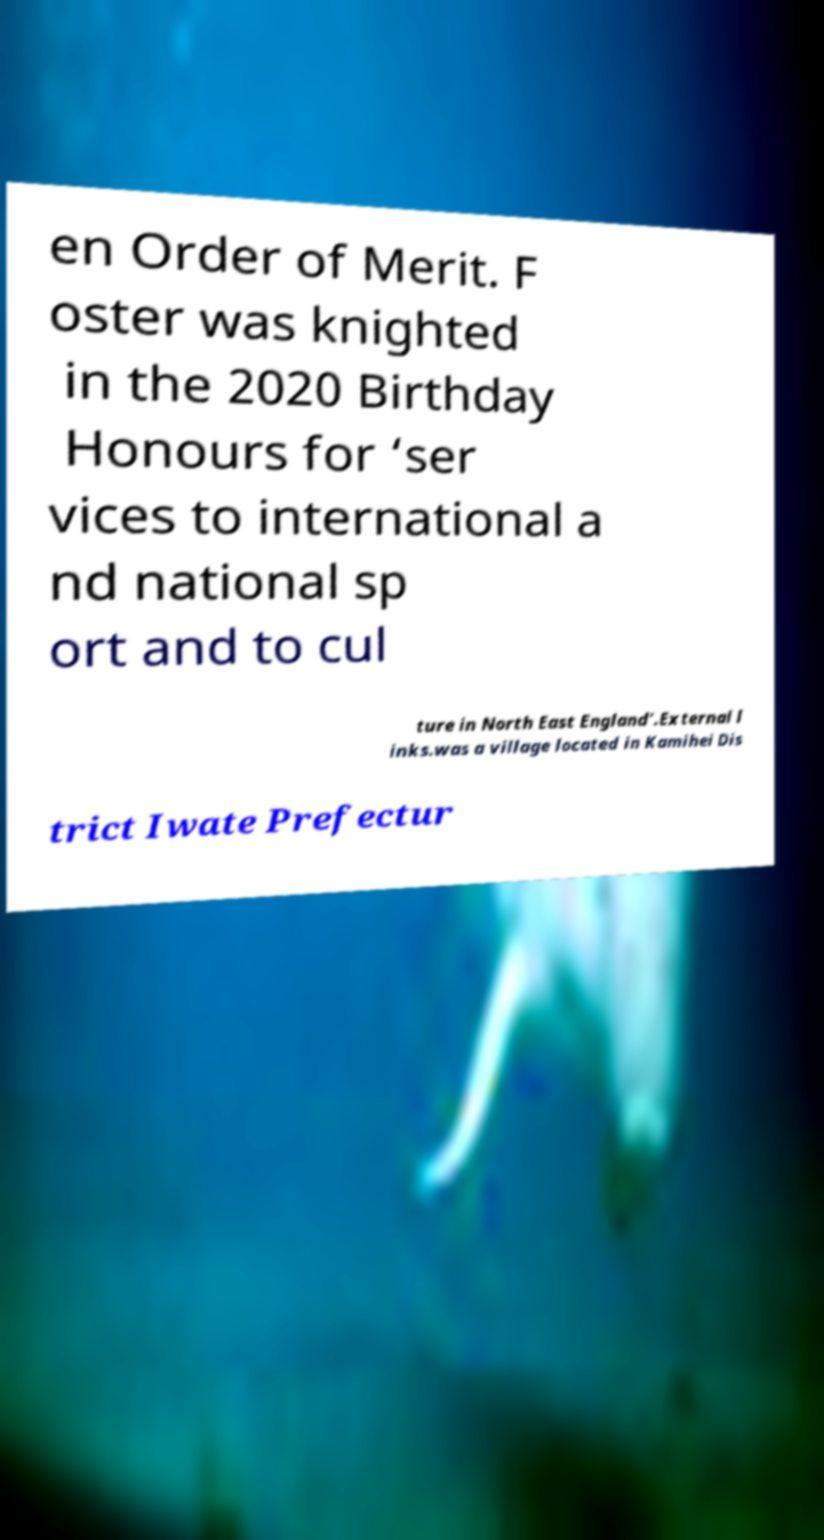What messages or text are displayed in this image? I need them in a readable, typed format. en Order of Merit. F oster was knighted in the 2020 Birthday Honours for ‘ser vices to international a nd national sp ort and to cul ture in North East England’.External l inks.was a village located in Kamihei Dis trict Iwate Prefectur 